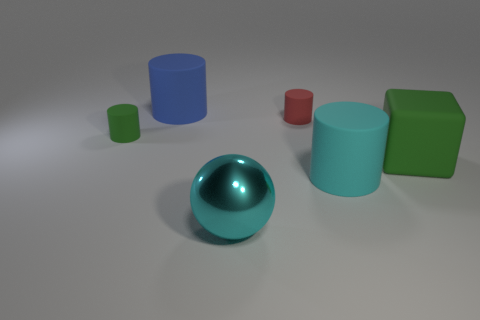Which object stands out the most due to its color and why? The cyan sphere stands out the most due to its vibrant, reflective surface which contrasts sharply with the matte surfaces of the other objects. 